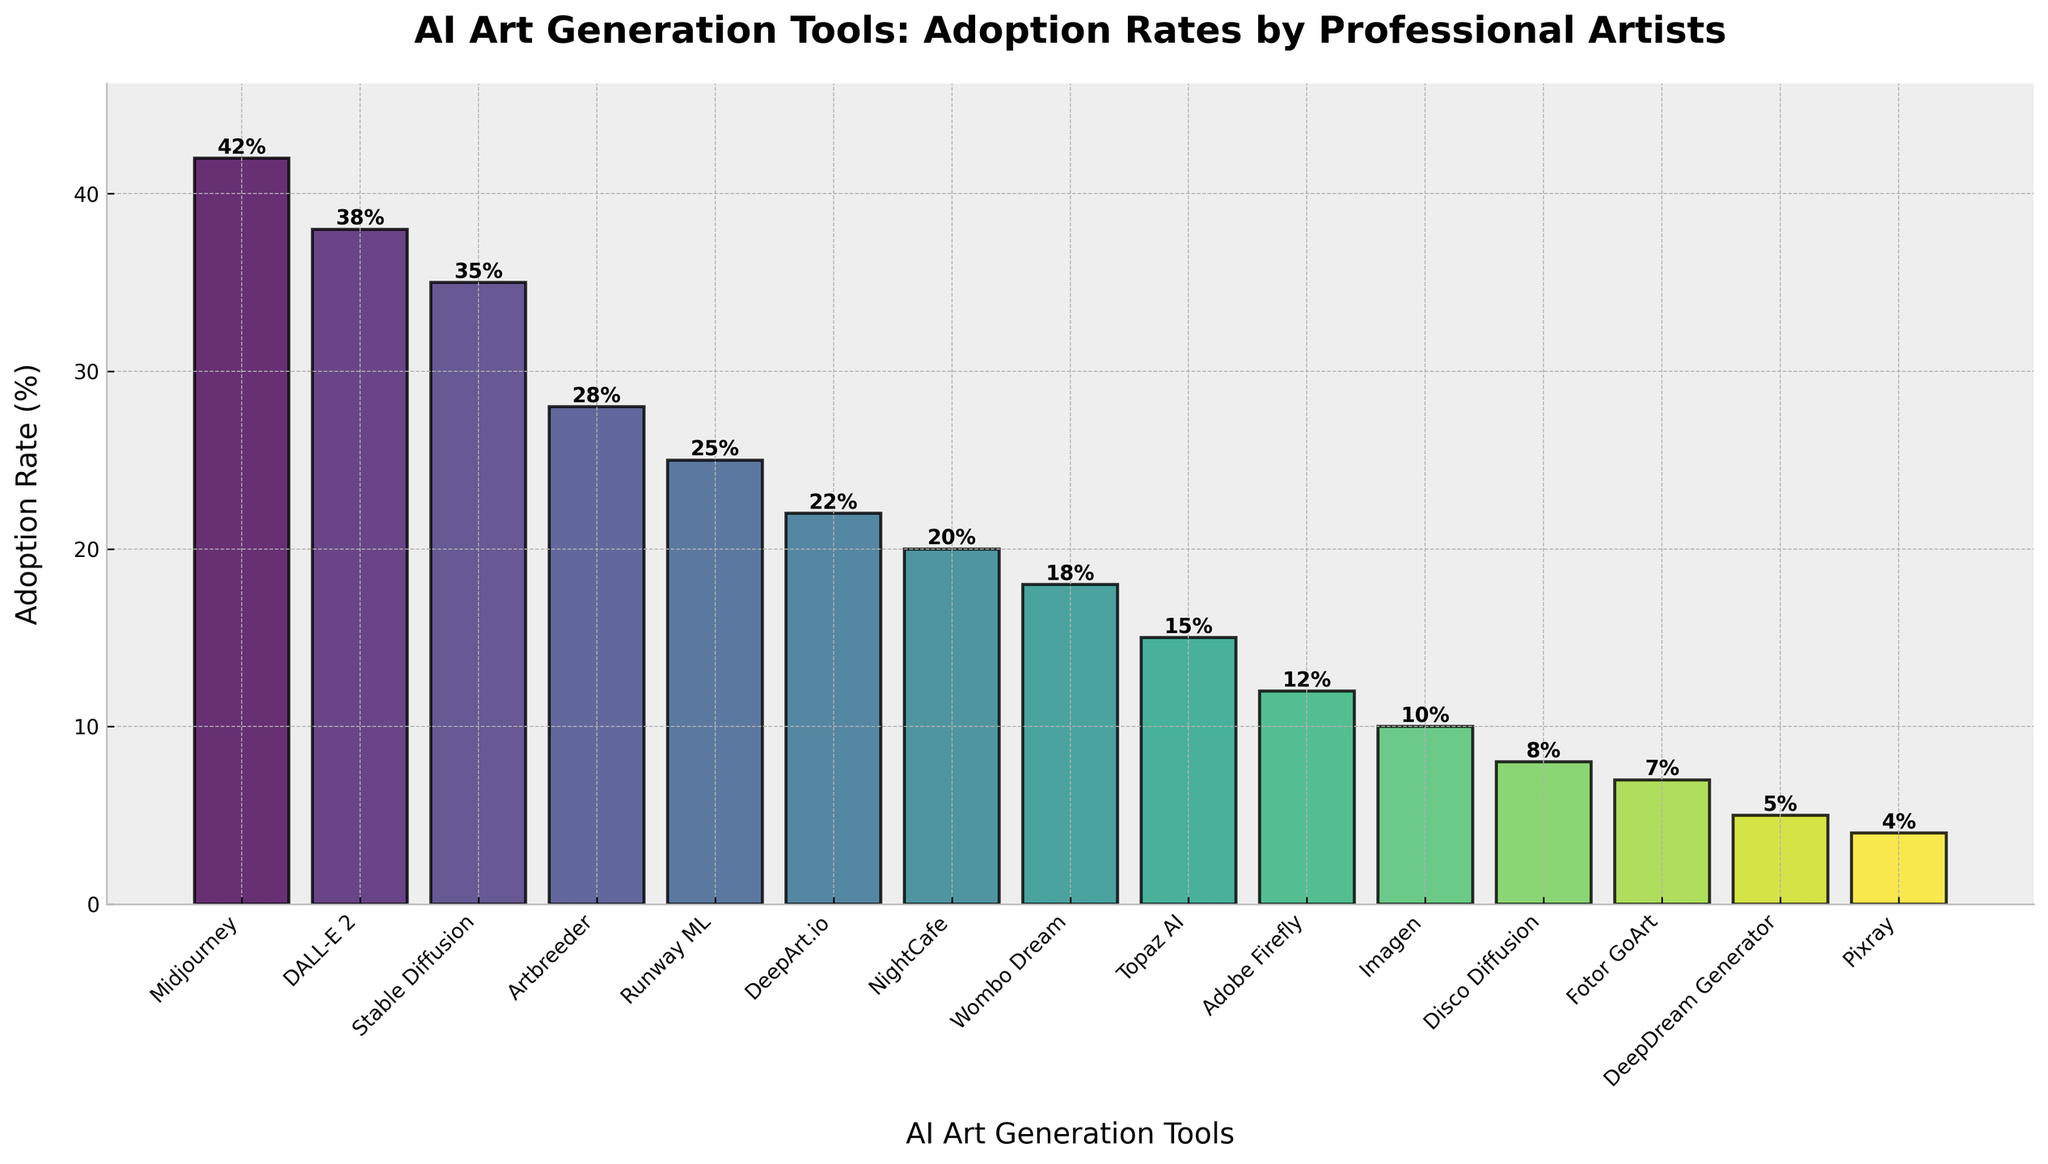Which AI art generation tool has the highest adoption rate? By examining the figure, the tallest bar indicates the tool with the highest adoption rate. The bar for Midjourney is the tallest.
Answer: Midjourney Which tool has a lower adoption rate: DALL-E 2 or Stable Diffusion? Compare the heights of the bars for DALL-E 2 and Stable Diffusion. The bar for Stable Diffusion is slightly shorter than the bar for DALL-E 2.
Answer: Stable Diffusion What is the total adoption rate of the top three AI art generation tools (Midjourney, DALL-E 2, Stable Diffusion)? Sum the adoption rates of the top three tools: Midjourney (42%), DALL-E 2 (38%), and Stable Diffusion (35%). 42 + 38 + 35 = 115
Answer: 115% Which tool has the smallest adoption rate from the figure? Identify the shortest bar in the figure. The bar for Pixray is the shortest.
Answer: Pixray How much higher is the adoption rate of Midjourney compared to Adobe Firefly? Subtract the adoption rate of Adobe Firefly (12%) from that of Midjourney (42%). 42 - 12 = 30
Answer: 30% What is the average adoption rate of all the AI art generation tools displayed? Sum up all the adoption rates and divide by the number of tools (15). (42 + 38 + 35 + 28 + 25 + 22 + 20 + 18 + 15 + 12 + 10 + 8 + 7 + 5 + 4) / 15 = 289 / 15 ≈ 19.27
Answer: 19.27% Which has a higher adoption rate: NightCafe or Runway ML? Compare the heights of the bars for NightCafe and Runway ML. The bar for Runway ML (25%) is higher than the bar for NightCafe (20%).
Answer: Runway ML If the adoption rates of the lowest three tools are removed, what is the new total adoption rate? Exclude the adoption rates of Pixray (4%), DeepDream Generator (5%), and Fotor GoArt (7%) from the total. Total = 289 - (4 + 5 + 7) = 289 - 16 = 273
Answer: 273% What is the difference in adoption rates between the most adopted and the least adopted tools? Subtract the adoption rate of Pixray (4%) from that of Midjourney (42%). 42 - 4 = 38
Answer: 38% How many tools have an adoption rate greater than 20%? Count the bars with an adoption rate higher than 20%. These are Midjourney, DALL-E 2, Stable Diffusion, Artbreeder, and Runway ML.
Answer: 5 